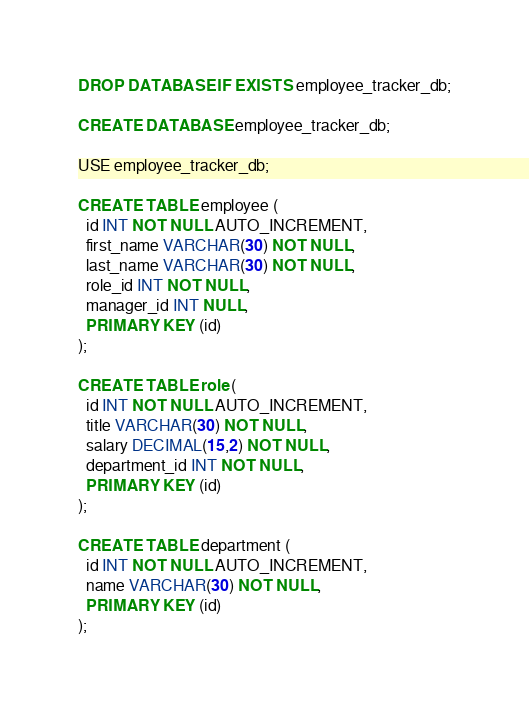<code> <loc_0><loc_0><loc_500><loc_500><_SQL_>DROP DATABASE IF EXISTS employee_tracker_db;

CREATE DATABASE employee_tracker_db;

USE employee_tracker_db;

CREATE TABLE employee (
  id INT NOT NULL AUTO_INCREMENT,
  first_name VARCHAR(30) NOT NULL,
  last_name VARCHAR(30) NOT NULL,
  role_id INT NOT NULL,
  manager_id INT NULL,
  PRIMARY KEY (id) 
);

CREATE TABLE role (
  id INT NOT NULL AUTO_INCREMENT,
  title VARCHAR(30) NOT NULL,
  salary DECIMAL(15,2) NOT NULL,
  department_id INT NOT NULL,
  PRIMARY KEY (id) 
);

CREATE TABLE department (
  id INT NOT NULL AUTO_INCREMENT,
  name VARCHAR(30) NOT NULL,
  PRIMARY KEY (id) 
);

</code> 